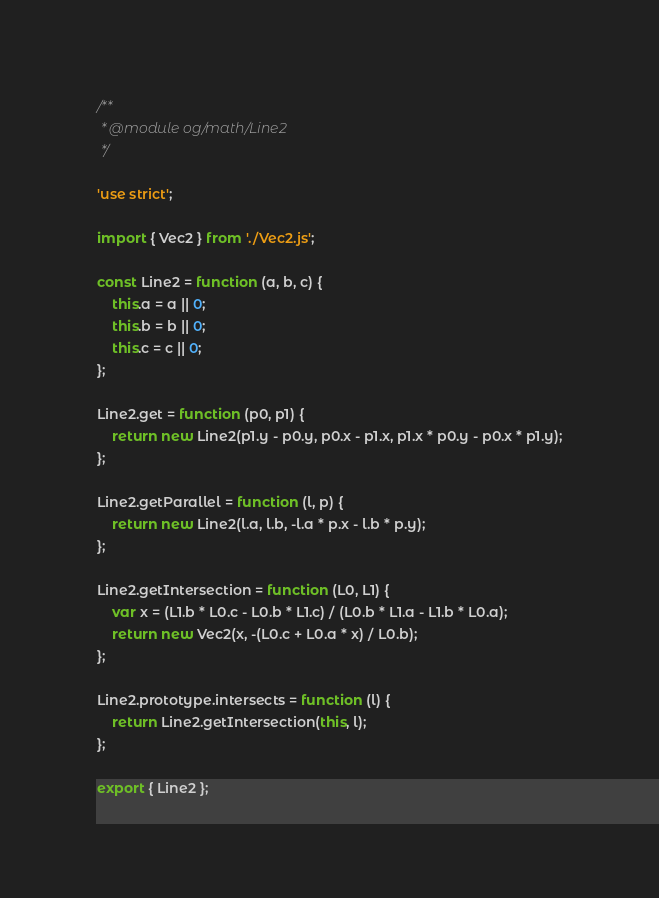Convert code to text. <code><loc_0><loc_0><loc_500><loc_500><_JavaScript_>/**
 * @module og/math/Line2
 */

'use strict';

import { Vec2 } from './Vec2.js';

const Line2 = function (a, b, c) {
    this.a = a || 0;
    this.b = b || 0;
    this.c = c || 0;
};

Line2.get = function (p0, p1) {
    return new Line2(p1.y - p0.y, p0.x - p1.x, p1.x * p0.y - p0.x * p1.y);
};

Line2.getParallel = function (l, p) {
    return new Line2(l.a, l.b, -l.a * p.x - l.b * p.y);
};

Line2.getIntersection = function (L0, L1) {
    var x = (L1.b * L0.c - L0.b * L1.c) / (L0.b * L1.a - L1.b * L0.a);
    return new Vec2(x, -(L0.c + L0.a * x) / L0.b);
};

Line2.prototype.intersects = function (l) {
    return Line2.getIntersection(this, l);
};

export { Line2 };</code> 